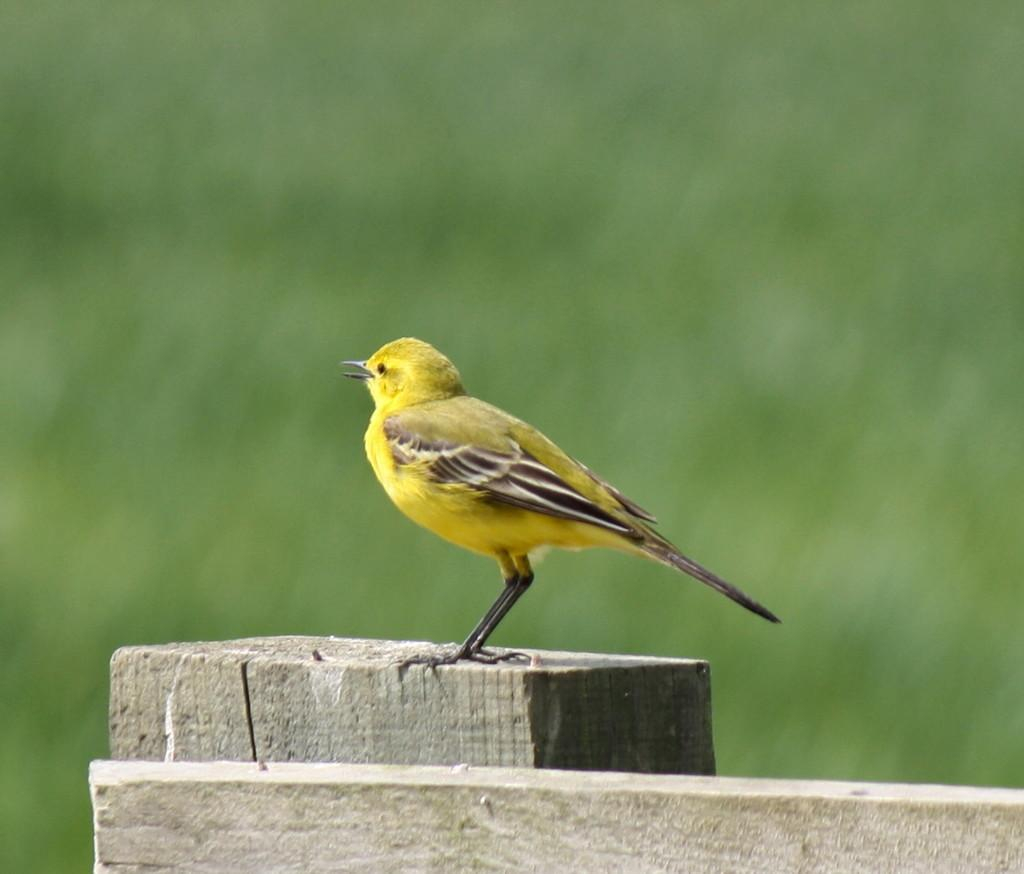What type of animal is in the image? There is a yellow bird in the image. Where is the bird located? The bird is standing on a fence. Can you describe the background of the image? The background of the image is blurry. What songs is the bird singing in the image? The image does not provide any information about the bird singing songs. 